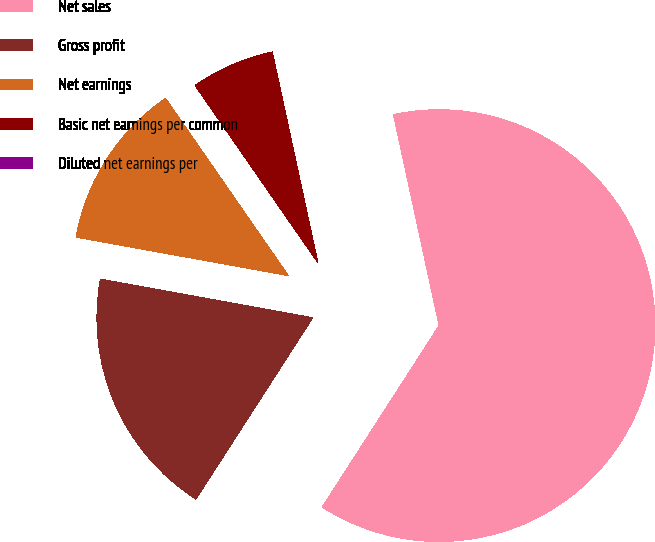<chart> <loc_0><loc_0><loc_500><loc_500><pie_chart><fcel>Net sales<fcel>Gross profit<fcel>Net earnings<fcel>Basic net earnings per common<fcel>Diluted net earnings per<nl><fcel>62.49%<fcel>18.75%<fcel>12.5%<fcel>6.25%<fcel>0.0%<nl></chart> 